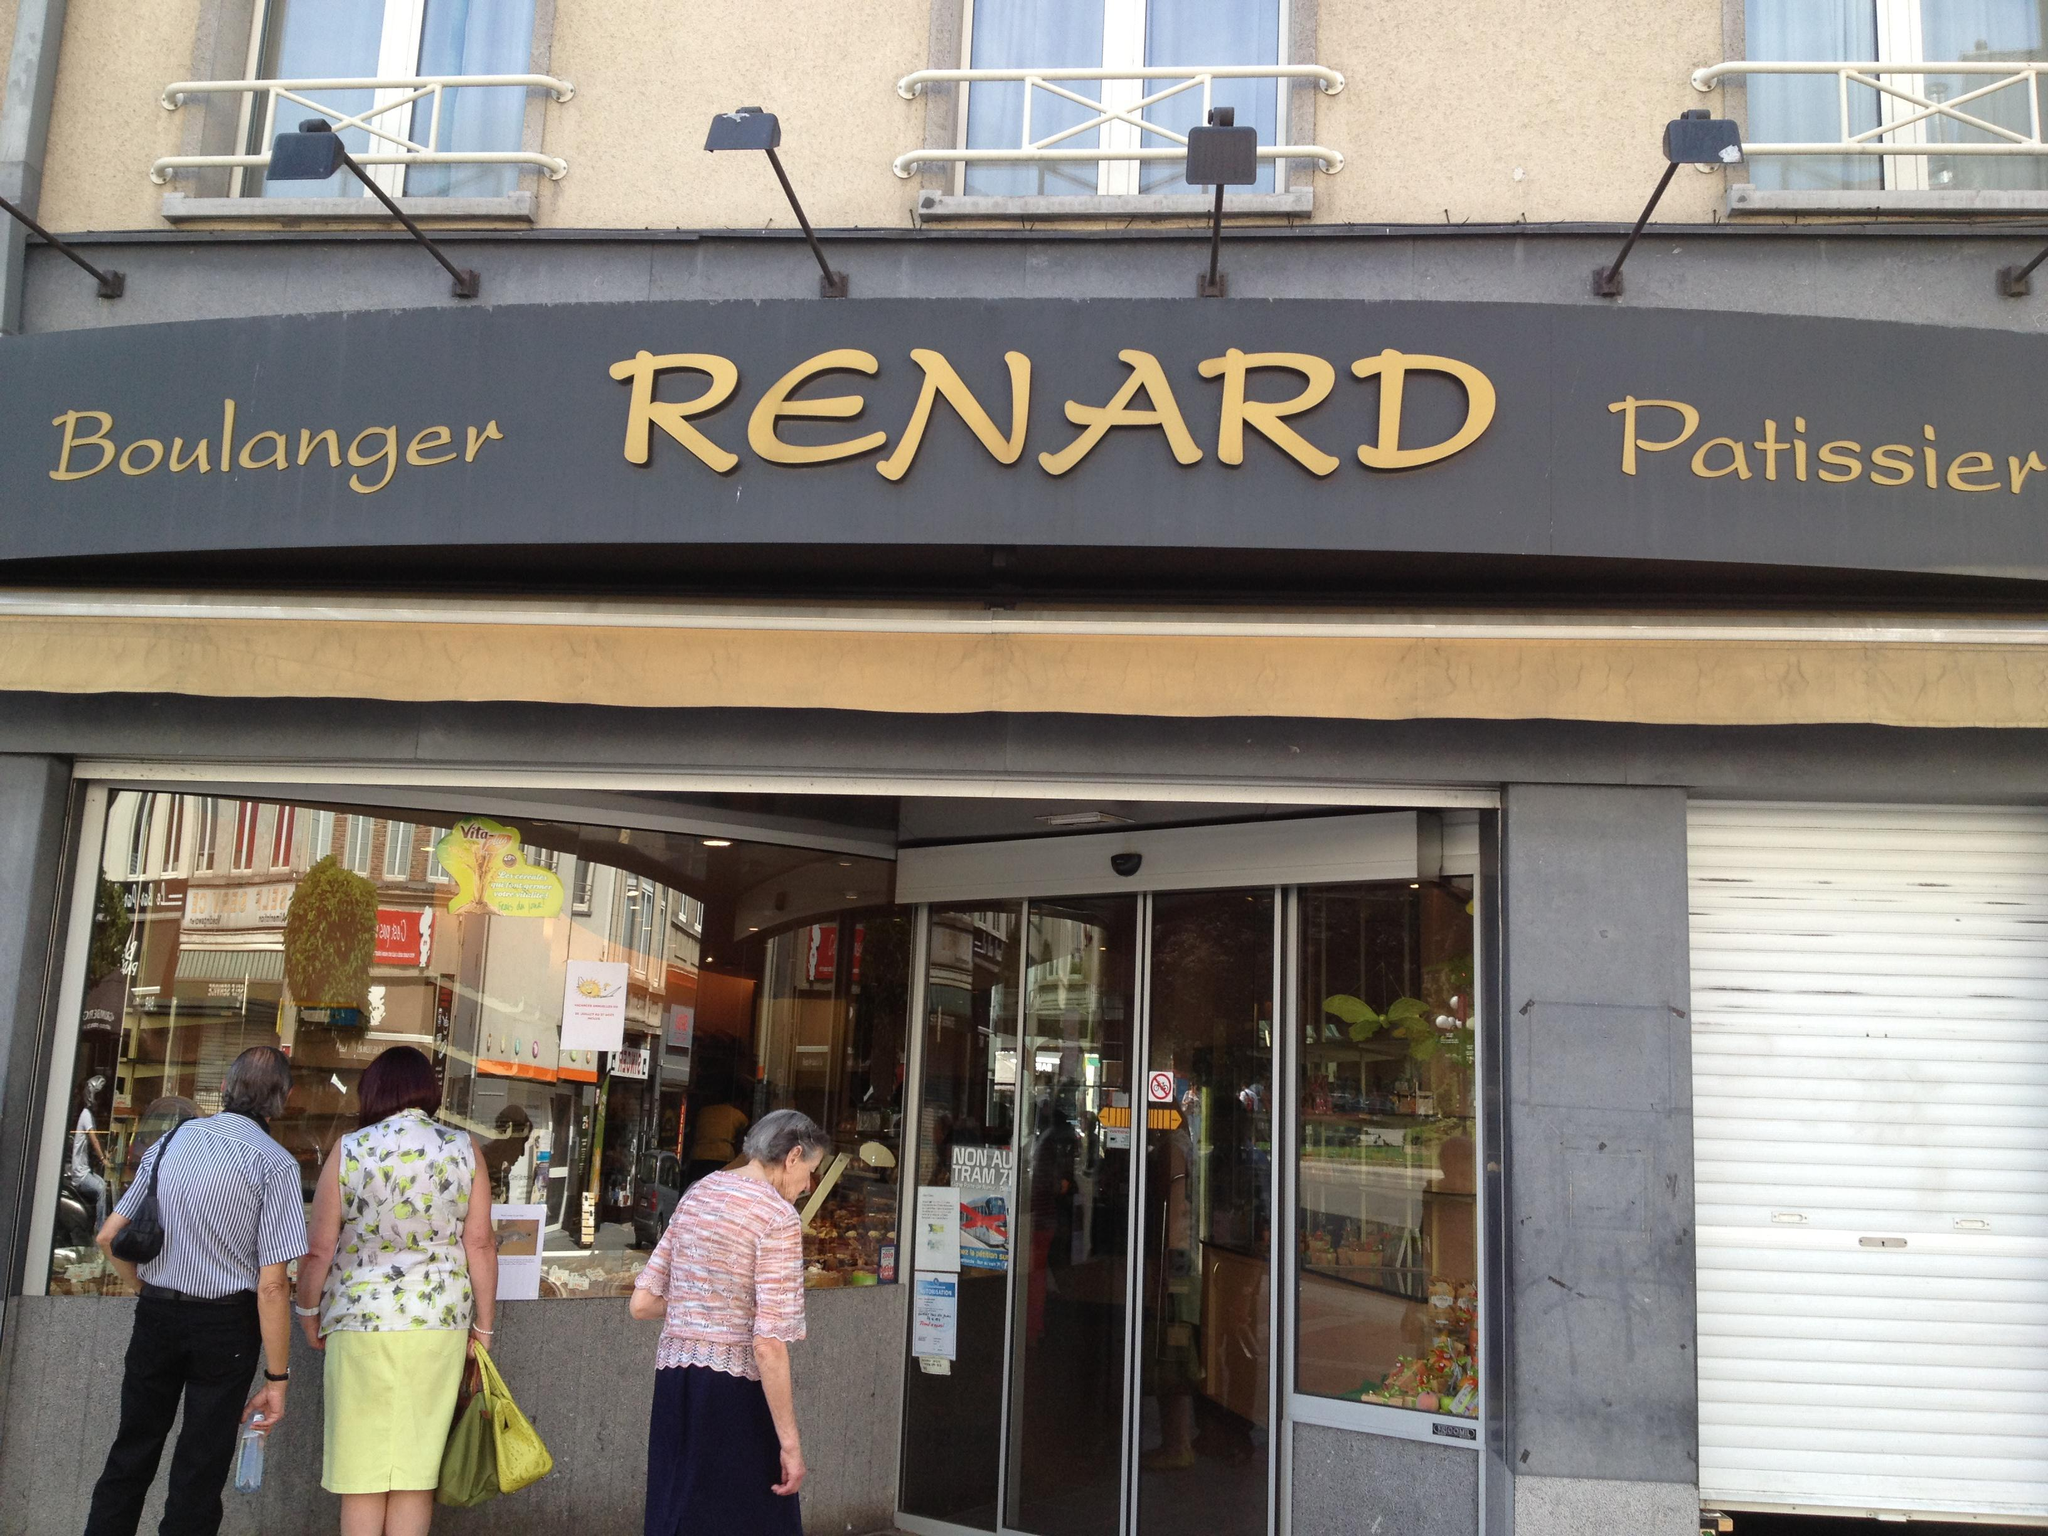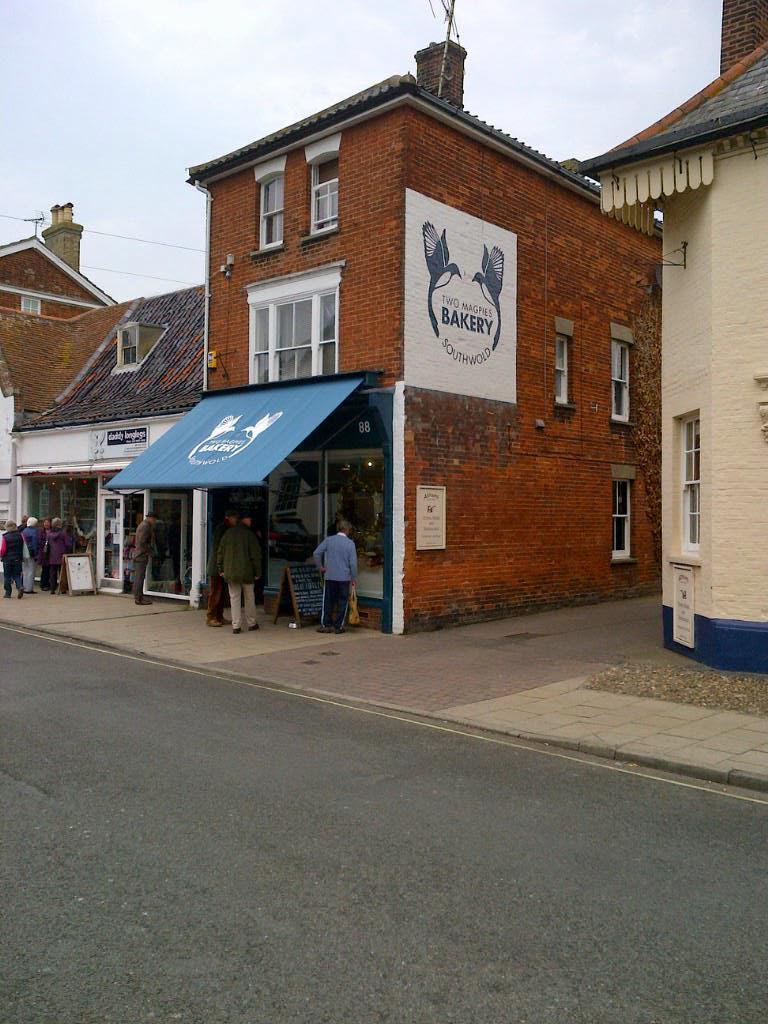The first image is the image on the left, the second image is the image on the right. Evaluate the accuracy of this statement regarding the images: "The building in one of the images has a blue awning.". Is it true? Answer yes or no. Yes. The first image is the image on the left, the second image is the image on the right. For the images displayed, is the sentence "there is a brick building with a blue fabric awning, above the awning is a white painted window" factually correct? Answer yes or no. Yes. 